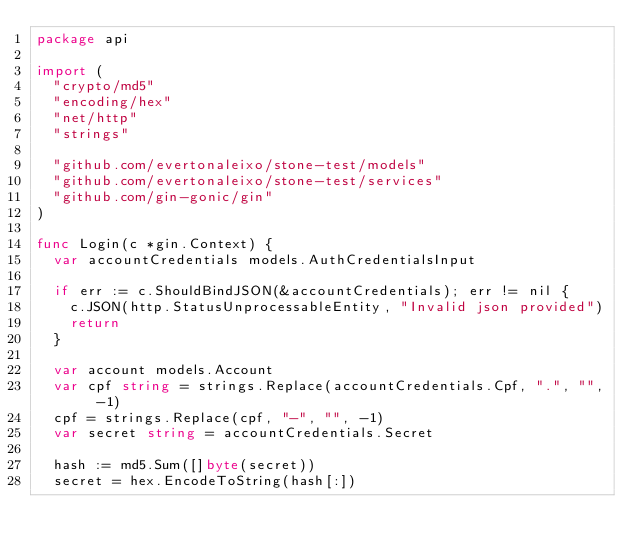<code> <loc_0><loc_0><loc_500><loc_500><_Go_>package api

import (
	"crypto/md5"
	"encoding/hex"
	"net/http"
	"strings"

	"github.com/evertonaleixo/stone-test/models"
	"github.com/evertonaleixo/stone-test/services"
	"github.com/gin-gonic/gin"
)

func Login(c *gin.Context) {
	var accountCredentials models.AuthCredentialsInput

	if err := c.ShouldBindJSON(&accountCredentials); err != nil {
		c.JSON(http.StatusUnprocessableEntity, "Invalid json provided")
		return
	}

	var account models.Account
	var cpf string = strings.Replace(accountCredentials.Cpf, ".", "", -1)
	cpf = strings.Replace(cpf, "-", "", -1)
	var secret string = accountCredentials.Secret

	hash := md5.Sum([]byte(secret))
	secret = hex.EncodeToString(hash[:])
</code> 